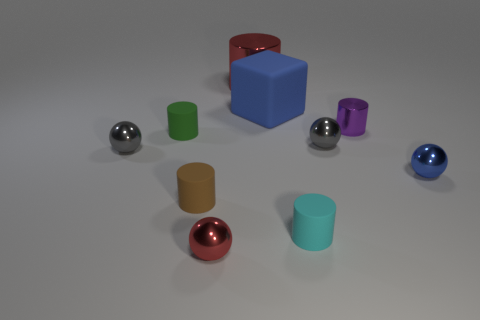Subtract all brown cylinders. How many cylinders are left? 4 Subtract all green matte cylinders. How many cylinders are left? 4 Subtract all cyan cylinders. Subtract all purple balls. How many cylinders are left? 4 Subtract all spheres. How many objects are left? 6 Add 9 purple objects. How many purple objects are left? 10 Add 4 tiny green matte objects. How many tiny green matte objects exist? 5 Subtract 0 blue cylinders. How many objects are left? 10 Subtract all green blocks. Subtract all tiny green things. How many objects are left? 9 